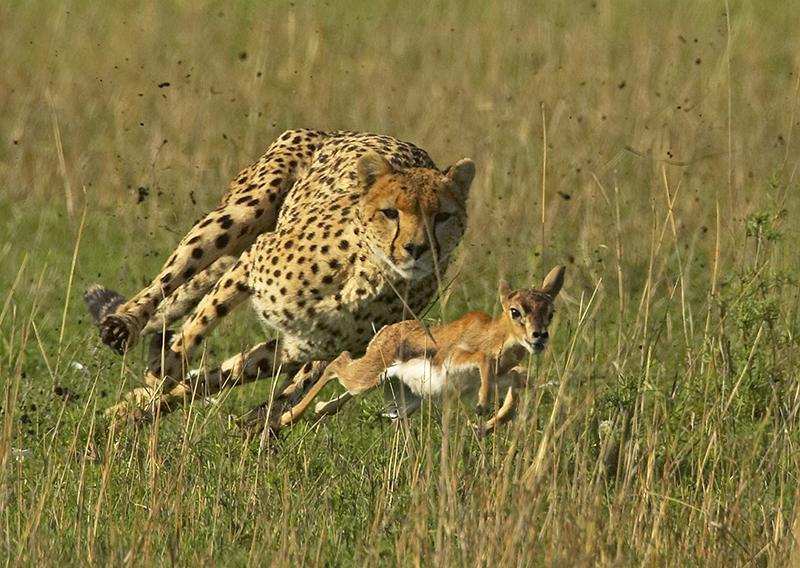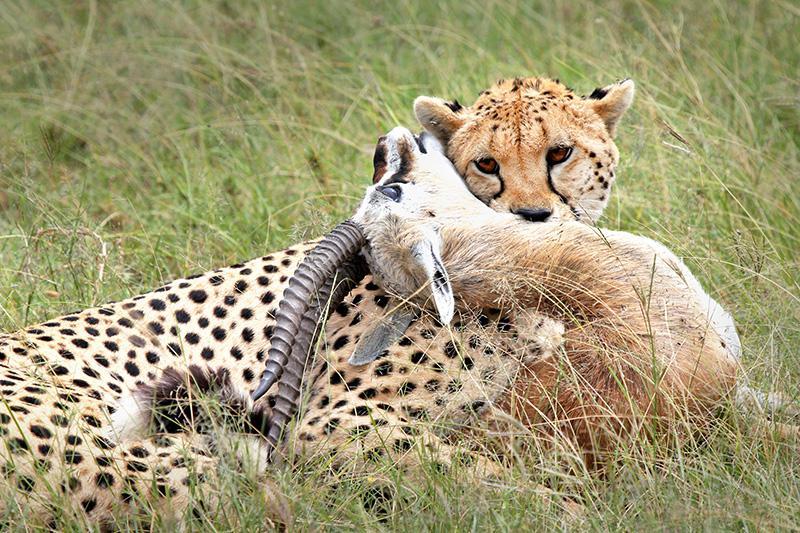The first image is the image on the left, the second image is the image on the right. Assess this claim about the two images: "One cheetah's teeth are visible.". Correct or not? Answer yes or no. No. The first image is the image on the left, the second image is the image on the right. Examine the images to the left and right. Is the description "The left image shows a forward angled adult cheetah on the grass on its haunches with a piece of red flesh in front of it." accurate? Answer yes or no. No. 